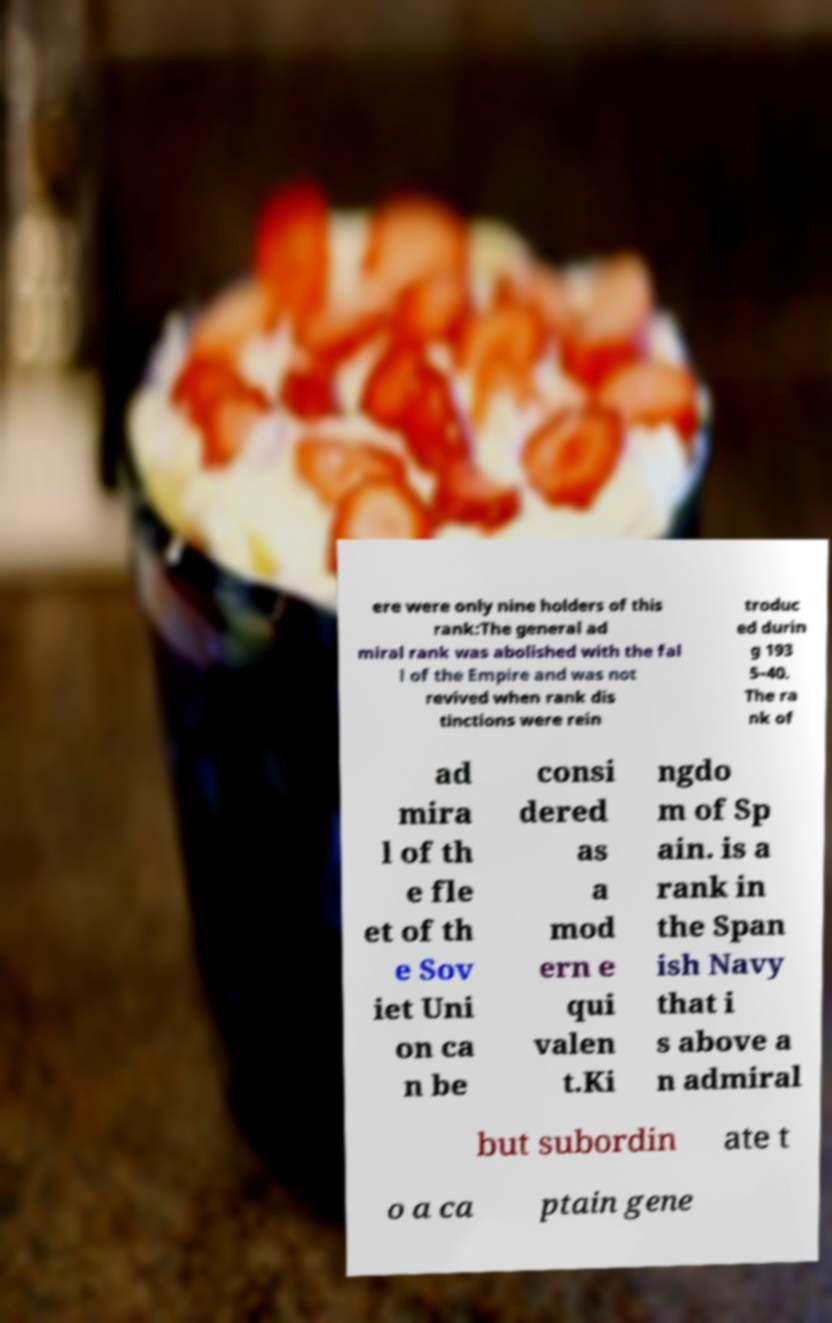Could you assist in decoding the text presented in this image and type it out clearly? ere were only nine holders of this rank:The general ad miral rank was abolished with the fal l of the Empire and was not revived when rank dis tinctions were rein troduc ed durin g 193 5–40. The ra nk of ad mira l of th e fle et of th e Sov iet Uni on ca n be consi dered as a mod ern e qui valen t.Ki ngdo m of Sp ain. is a rank in the Span ish Navy that i s above a n admiral but subordin ate t o a ca ptain gene 